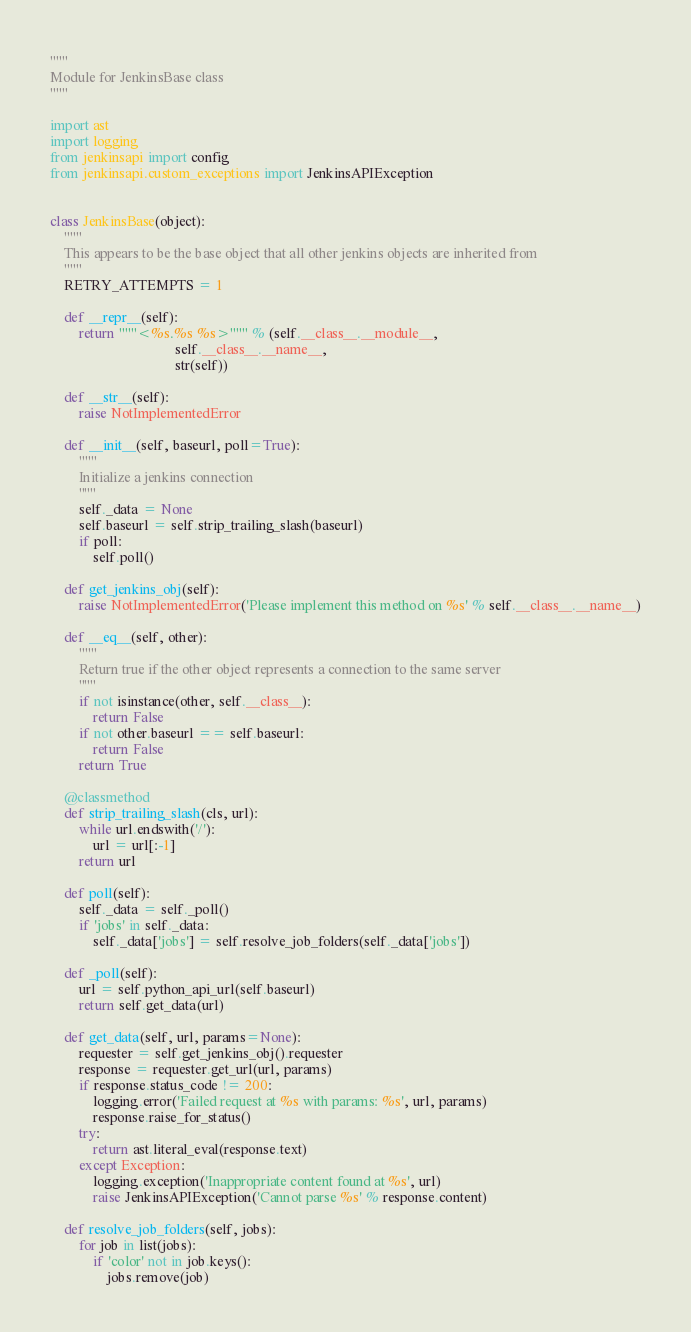Convert code to text. <code><loc_0><loc_0><loc_500><loc_500><_Python_>"""
Module for JenkinsBase class
"""

import ast
import logging
from jenkinsapi import config
from jenkinsapi.custom_exceptions import JenkinsAPIException


class JenkinsBase(object):
    """
    This appears to be the base object that all other jenkins objects are inherited from
    """
    RETRY_ATTEMPTS = 1

    def __repr__(self):
        return """<%s.%s %s>""" % (self.__class__.__module__,
                                   self.__class__.__name__,
                                   str(self))

    def __str__(self):
        raise NotImplementedError

    def __init__(self, baseurl, poll=True):
        """
        Initialize a jenkins connection
        """
        self._data = None
        self.baseurl = self.strip_trailing_slash(baseurl)
        if poll:
            self.poll()

    def get_jenkins_obj(self):
        raise NotImplementedError('Please implement this method on %s' % self.__class__.__name__)

    def __eq__(self, other):
        """
        Return true if the other object represents a connection to the same server
        """
        if not isinstance(other, self.__class__):
            return False
        if not other.baseurl == self.baseurl:
            return False
        return True

    @classmethod
    def strip_trailing_slash(cls, url):
        while url.endswith('/'):
            url = url[:-1]
        return url

    def poll(self):
        self._data = self._poll()
        if 'jobs' in self._data:
            self._data['jobs'] = self.resolve_job_folders(self._data['jobs'])

    def _poll(self):
        url = self.python_api_url(self.baseurl)
        return self.get_data(url)

    def get_data(self, url, params=None):
        requester = self.get_jenkins_obj().requester
        response = requester.get_url(url, params)
        if response.status_code != 200:
            logging.error('Failed request at %s with params: %s', url, params)
            response.raise_for_status()
        try:
            return ast.literal_eval(response.text)
        except Exception:
            logging.exception('Inappropriate content found at %s', url)
            raise JenkinsAPIException('Cannot parse %s' % response.content)

    def resolve_job_folders(self, jobs):
        for job in list(jobs):
            if 'color' not in job.keys():
                jobs.remove(job)</code> 